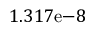Convert formula to latex. <formula><loc_0><loc_0><loc_500><loc_500>1 . 3 1 7 e { - 8 }</formula> 